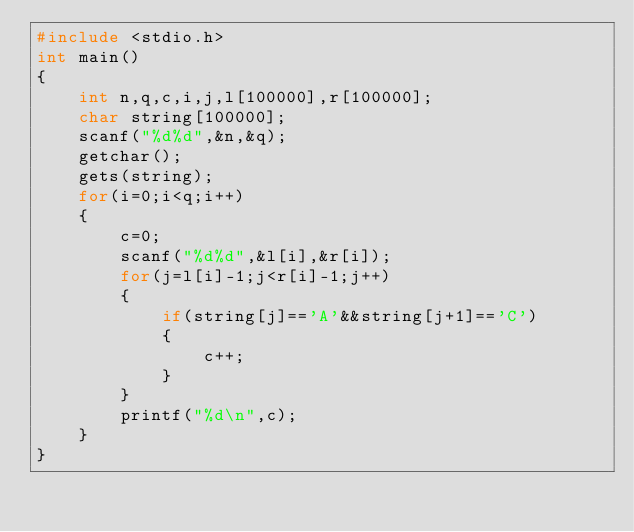<code> <loc_0><loc_0><loc_500><loc_500><_C_>#include <stdio.h>
int main()
{
    int n,q,c,i,j,l[100000],r[100000];
    char string[100000];
    scanf("%d%d",&n,&q);
    getchar();
    gets(string);
    for(i=0;i<q;i++)
    {
        c=0;
        scanf("%d%d",&l[i],&r[i]);
        for(j=l[i]-1;j<r[i]-1;j++)
        {
            if(string[j]=='A'&&string[j+1]=='C')
            {
                c++;
            }
        }
        printf("%d\n",c);
    }
}</code> 